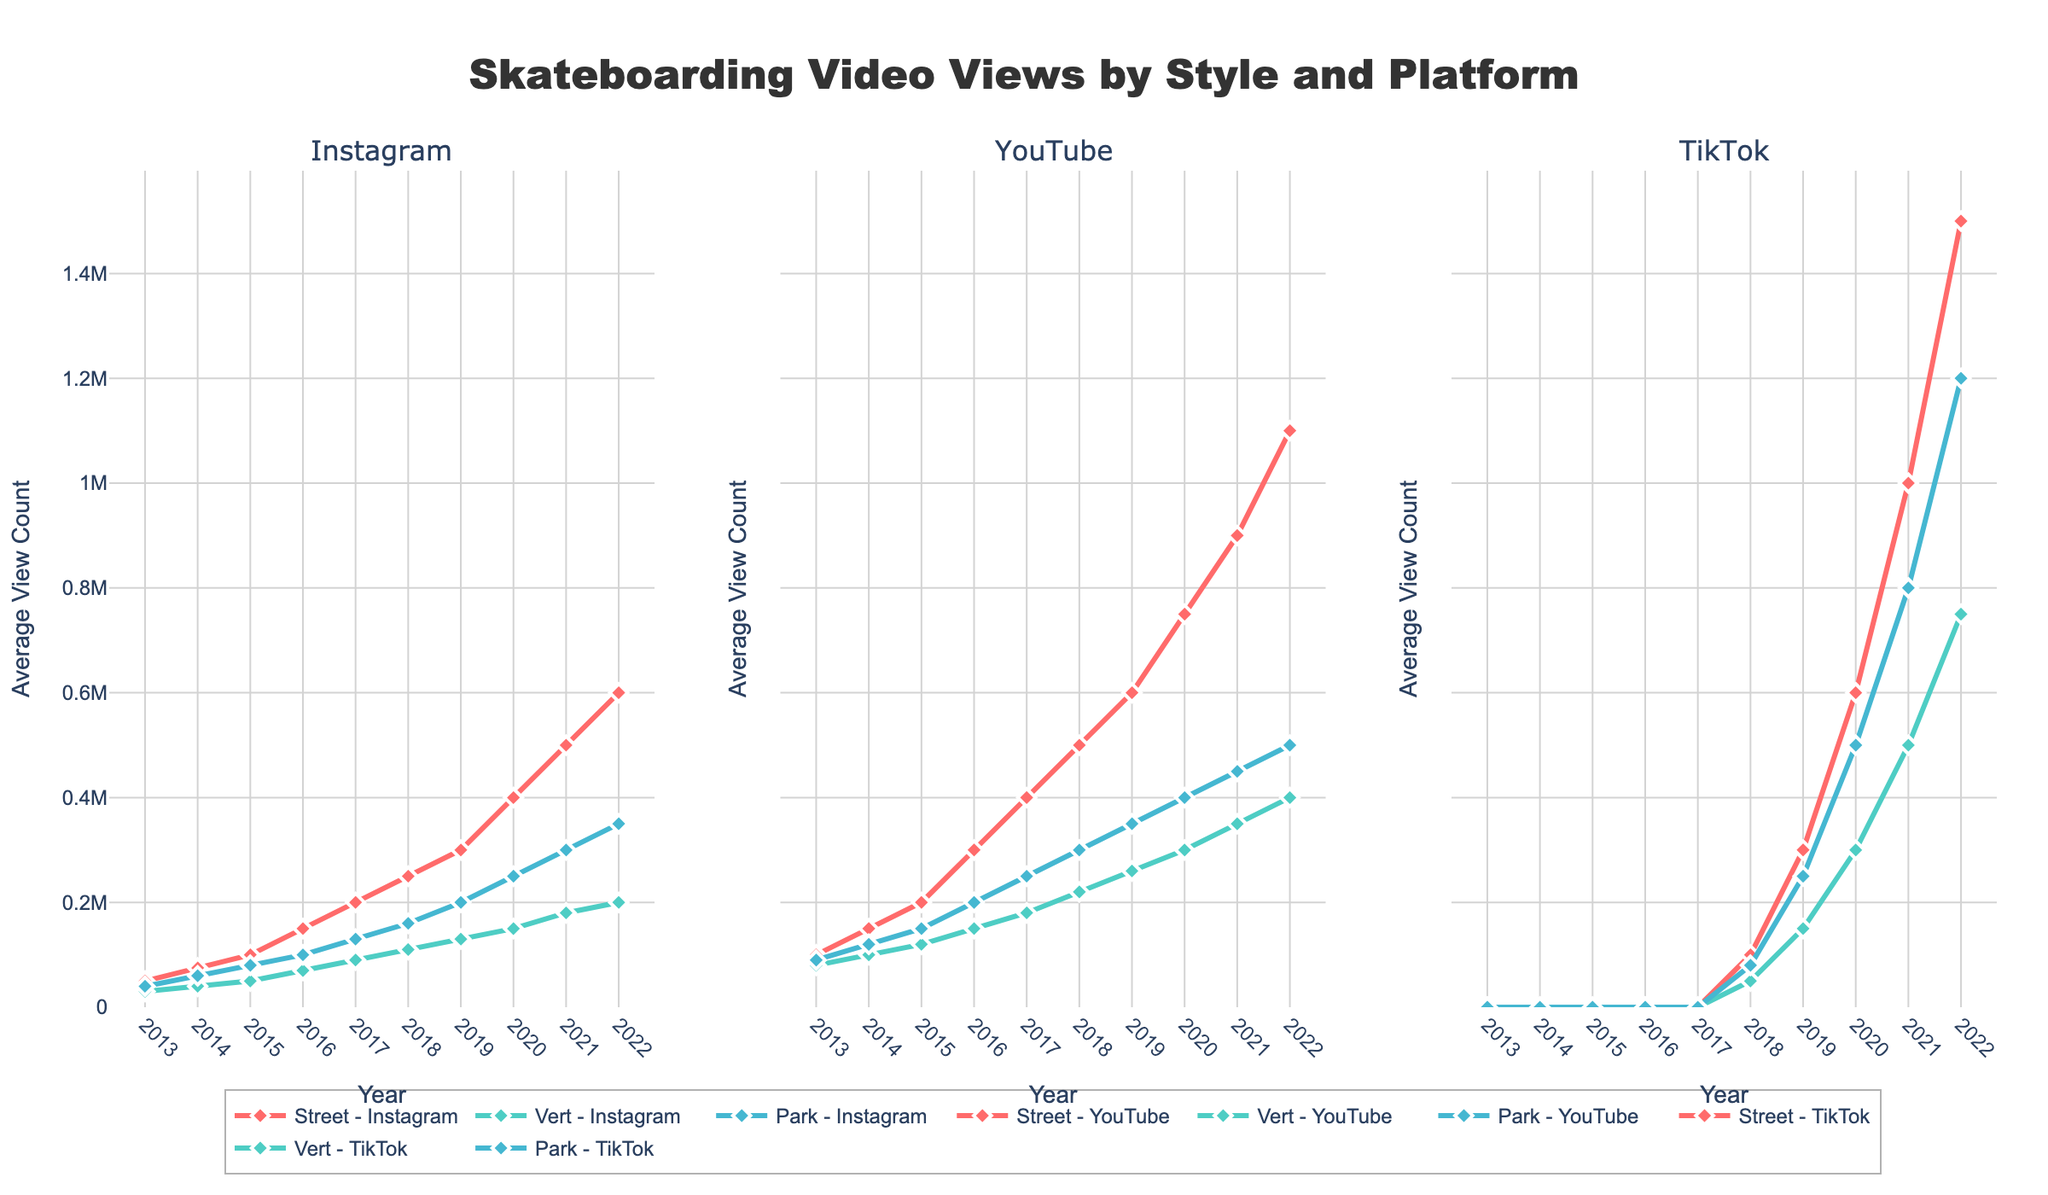Which skateboarding style has the highest average view count on TikTok in 2022? First, go to the TikTok column for the year 2022. Look at the values for Street, Vert, and Park styles. Compare the values: Street-1500000, Vert-750000, Park-1200000. The highest value is for Street.
Answer: Street How did the view count for Vert skateboarding on YouTube change from 2013 to 2018? Look at the Vert-YouTube values for 2013 and 2018. The values are 80000 in 2013 and 220000 in 2018. Compute the difference: 220000 - 80000 = 140000.
Answer: Increased by 140000 Which platform saw the most significant increase in views for Street skateboarding between 2019 and 2022? Look at the Street values for Instagram, YouTube, and TikTok from 2019 to 2022. Street-Instagram increased from 300000 to 600000 (300000 increase), Street-YouTube from 600000 to 1100000 (500000 increase), Street-TikTok from 300000 to 1500000 (1200000 increase). The most significant increase was on TikTok.
Answer: TikTok In 2020, which skateboarding style on TikTok had the lowest view count? Look at the TikTok column for 2020. Compare the values for Street, Vert, and Park styles: Street-600000, Vert-300000, Park-500000. The lowest value is for Vert.
Answer: Vert By how much did the view count for Park skateboarding on Instagram exceed Vert skateboarding on Instagram in 2021? Look at the values for Park-Instagram and Vert-Instagram in 2021. Park-Instagram is 300000, Vert-Instagram is 180000. Compute the difference: 300000 - 180000 = 120000.
Answer: 120000 Which style saw the least growth on YouTube from 2017 to 2022? Check the YouTube values for Street, Vert, and Park from 2017 to 2022:
- Street: 400000 to 1100000 (700000 growth)
- Vert: 180000 to 400000 (220000 growth)
- Park: 250000 to 500000 (250000 growth)
The least growth was for Vert with 220000.
Answer: Vert Between which years did the TikTok view count for Street skateboarding reach 1 million? Look at the TikTok values for Street skateboarding. The value reaches 1 million in 2021, showing it was between 2020 and 2021.
Answer: 2020 to 2021 Did the average view count for any skateboarding style on Instagram exceed those on YouTube before TikTok data started appearing? Look at the Instagram and YouTube values for each style from 2013 to 2017 (before TikTok data appears). For all styles (Street, Vert, and Park), the YouTube values are consistently higher than Instagram values.
Answer: No On which platform did Park skateboarding surpass 1 million views first, and in which year? Look at the Park values across all platforms. The first instance where it surpasses 1 million is on TikTok in 2022.
Answer: TikTok, 2022 